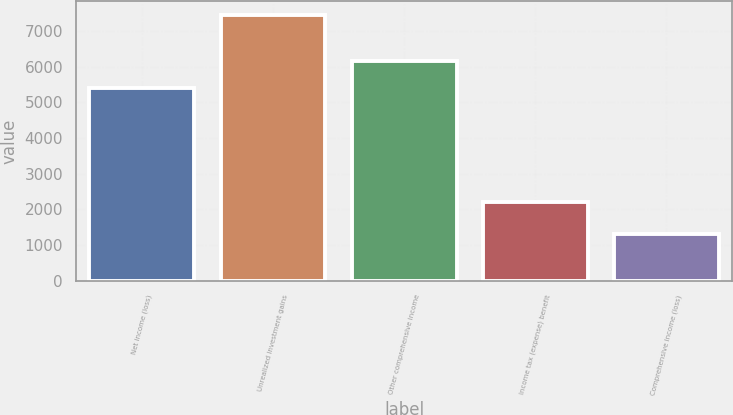Convert chart. <chart><loc_0><loc_0><loc_500><loc_500><bar_chart><fcel>Net income (loss)<fcel>Unrealized investment gains<fcel>Other comprehensive income<fcel>Income tax (expense) benefit<fcel>Comprehensive income (loss)<nl><fcel>5385<fcel>7449<fcel>6143.8<fcel>2203<fcel>1300.8<nl></chart> 